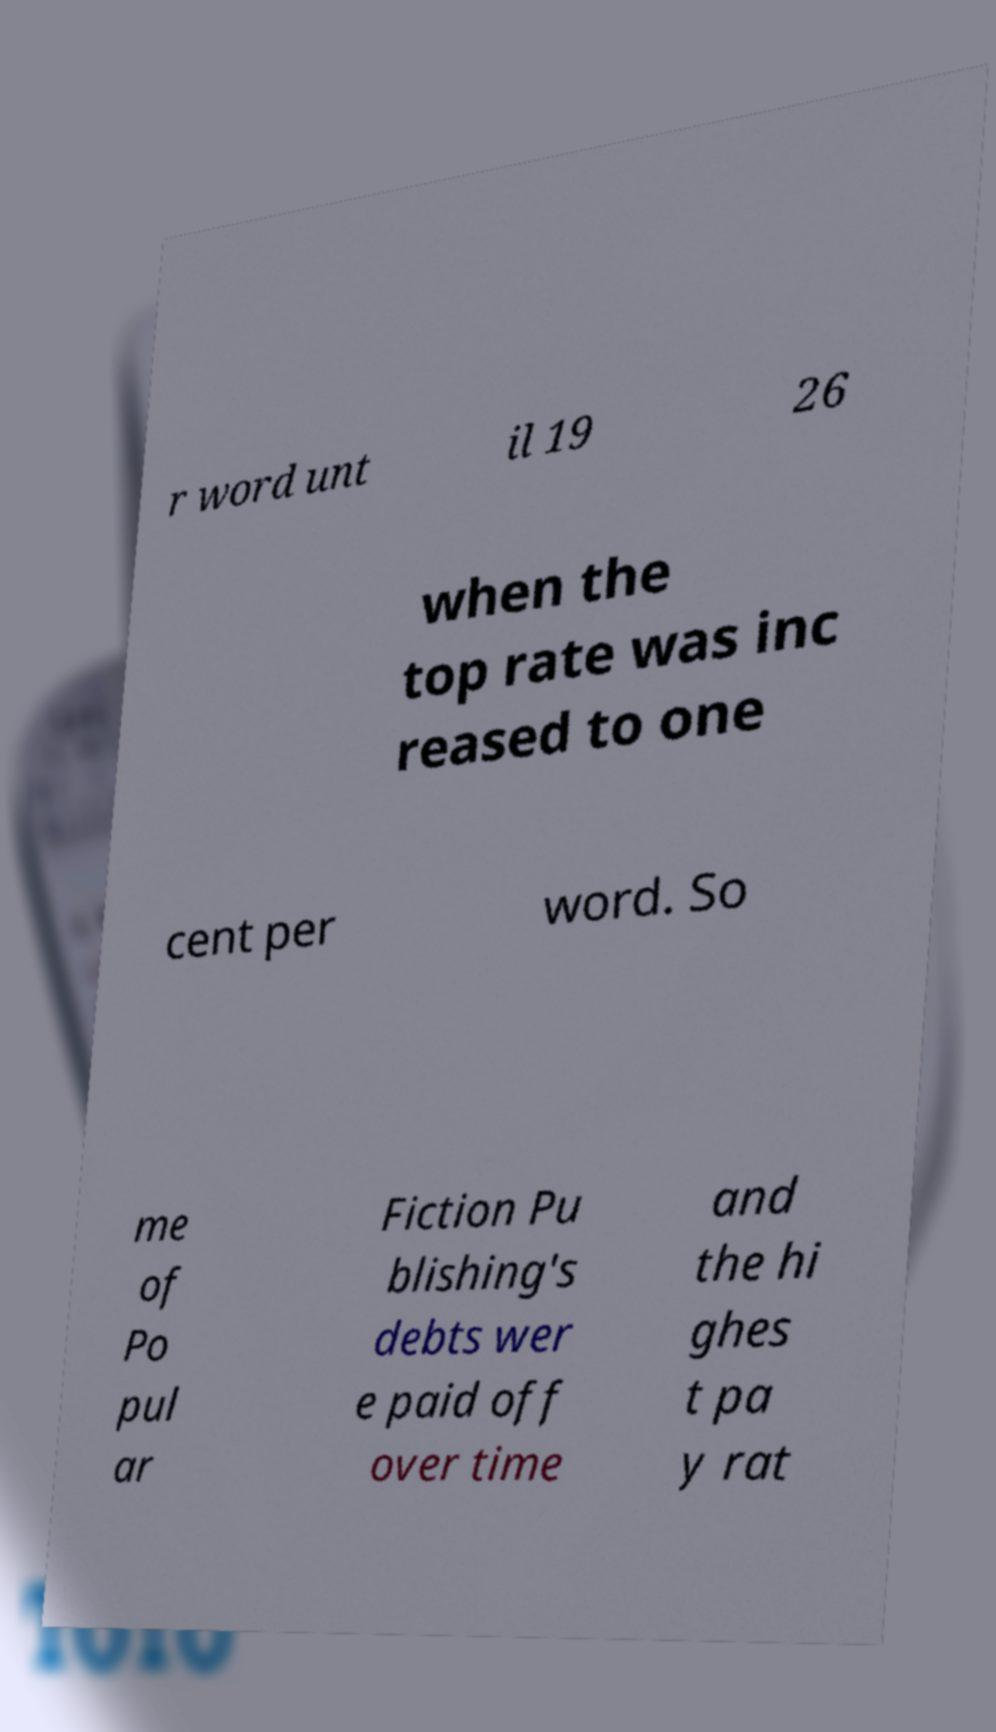For documentation purposes, I need the text within this image transcribed. Could you provide that? r word unt il 19 26 when the top rate was inc reased to one cent per word. So me of Po pul ar Fiction Pu blishing's debts wer e paid off over time and the hi ghes t pa y rat 